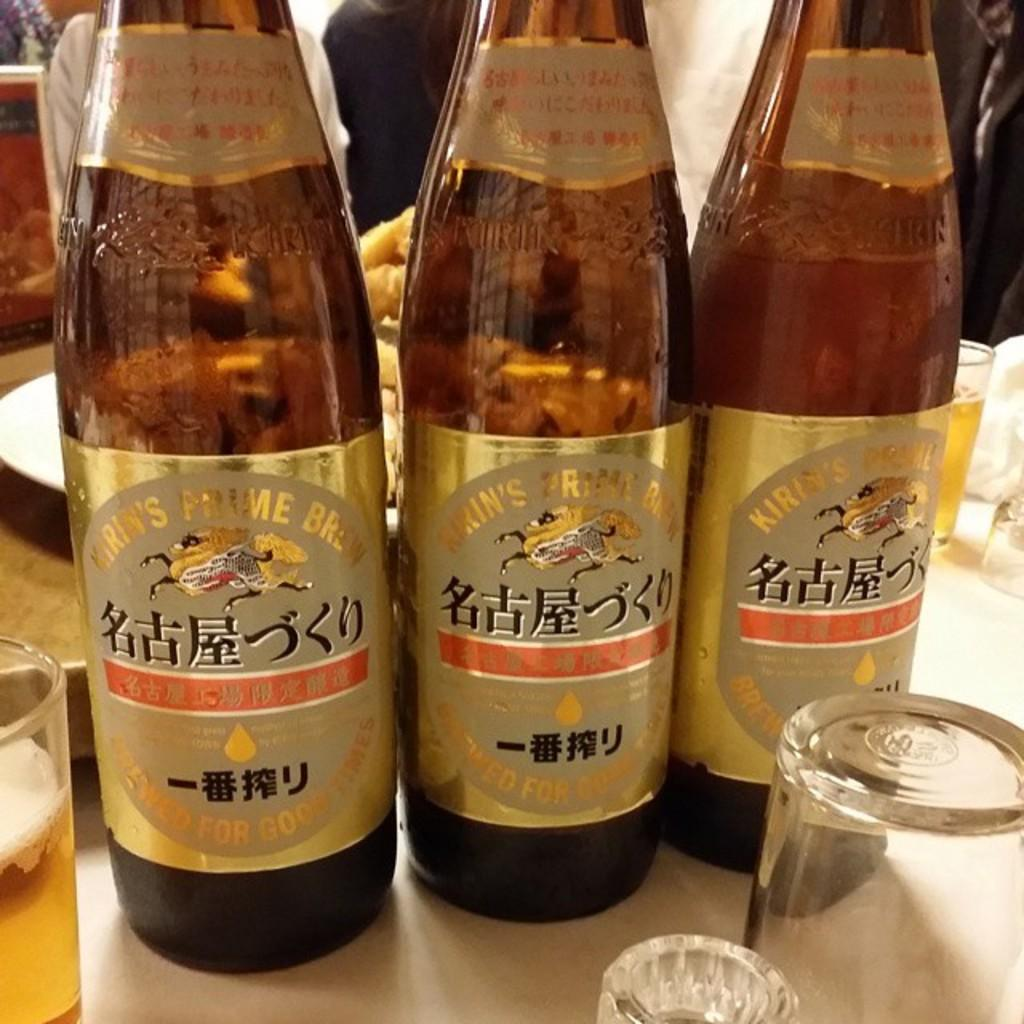<image>
Present a compact description of the photo's key features. Three Kirin beer bottles placed on a table. 